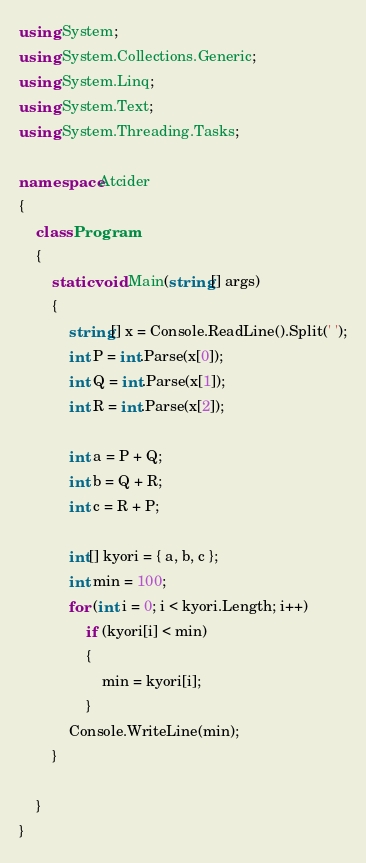<code> <loc_0><loc_0><loc_500><loc_500><_C#_>using System;
using System.Collections.Generic;
using System.Linq;
using System.Text;
using System.Threading.Tasks;

namespace Atcider
{
    class Program
    {
        static void Main(string[] args)
        {
            string[] x = Console.ReadLine().Split(' ');
            int P = int.Parse(x[0]);
            int Q = int.Parse(x[1]);
            int R = int.Parse(x[2]);

            int a = P + Q;
            int b = Q + R;
            int c = R + P;

            int[] kyori = { a, b, c };
            int min = 100;
            for (int i = 0; i < kyori.Length; i++)
                if (kyori[i] < min)
                {
                    min = kyori[i];
                }
            Console.WriteLine(min);
        }

    }  
}
</code> 